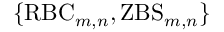Convert formula to latex. <formula><loc_0><loc_0><loc_500><loc_500>\{ R B C _ { m , n } , Z B S _ { m , n } \}</formula> 